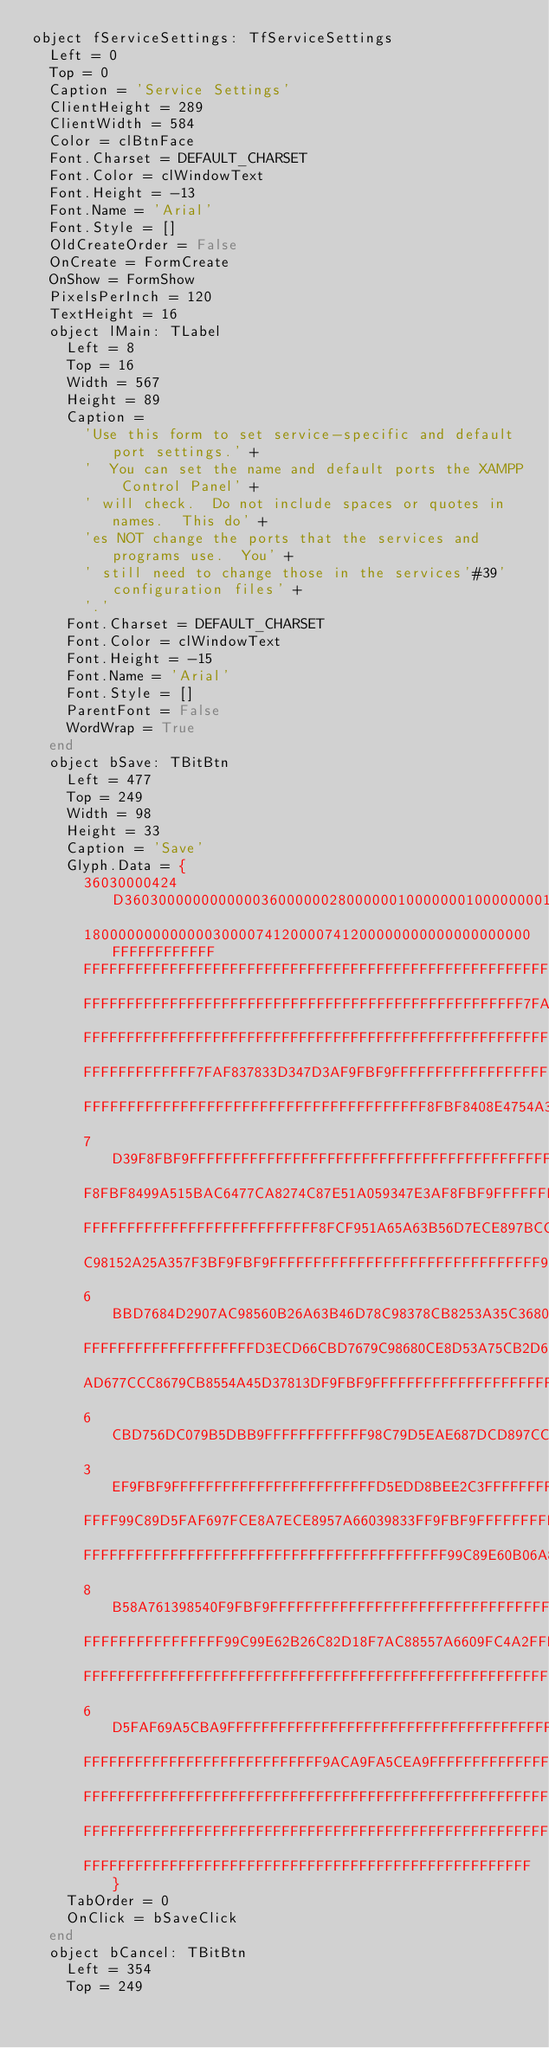<code> <loc_0><loc_0><loc_500><loc_500><_Pascal_>object fServiceSettings: TfServiceSettings
  Left = 0
  Top = 0
  Caption = 'Service Settings'
  ClientHeight = 289
  ClientWidth = 584
  Color = clBtnFace
  Font.Charset = DEFAULT_CHARSET
  Font.Color = clWindowText
  Font.Height = -13
  Font.Name = 'Arial'
  Font.Style = []
  OldCreateOrder = False
  OnCreate = FormCreate
  OnShow = FormShow
  PixelsPerInch = 120
  TextHeight = 16
  object lMain: TLabel
    Left = 8
    Top = 16
    Width = 567
    Height = 89
    Caption = 
      'Use this form to set service-specific and default port settings.' +
      '  You can set the name and default ports the XAMPP Control Panel' +
      ' will check.  Do not include spaces or quotes in names.  This do' +
      'es NOT change the ports that the services and programs use.  You' +
      ' still need to change those in the services'#39' configuration files' +
      '.'
    Font.Charset = DEFAULT_CHARSET
    Font.Color = clWindowText
    Font.Height = -15
    Font.Name = 'Arial'
    Font.Style = []
    ParentFont = False
    WordWrap = True
  end
  object bSave: TBitBtn
    Left = 477
    Top = 249
    Width = 98
    Height = 33
    Caption = 'Save'
    Glyph.Data = {
      36030000424D3603000000000000360000002800000010000000100000000100
      1800000000000003000074120000741200000000000000000000FFFFFFFFFFFF
      FFFFFFFFFFFFFFFFFFFFFFFFFFFFFFFFFFFFFFFFFFFFFFFFFFFFFFFFFFFFFFFF
      FFFFFFFFFFFFFFFFFFFFFFFFFFFFFFFFFFFFFFFFFFFFFFFFFFF7FAF7F9FBF9FF
      FFFFFFFFFFFFFFFFFFFFFFFFFFFFFFFFFFFFFFFFFFFFFFFFFFFFFFFFFFFFFFFF
      FFFFFFFFFFFFF7FAF837833D347D3AF9FBF9FFFFFFFFFFFFFFFFFFFFFFFFFFFF
      FFFFFFFFFFFFFFFFFFFFFFFFFFFFFFFFFFFFFFF8FBF8408E4754A35C4F9F5733
      7D39F8FBF9FFFFFFFFFFFFFFFFFFFFFFFFFFFFFFFFFFFFFFFFFFFFFFFFFFFFFF
      F8FBF8499A515BAC6477CA8274C87E51A059347E3AF8FBF9FFFFFFFFFFFFFFFF
      FFFFFFFFFFFFFFFFFFFFFFFFFFF8FCF951A65A63B56D7ECE897BCC8776CA8176
      C98152A25A357F3BF9FBF9FFFFFFFFFFFFFFFFFFFFFFFFFFFFFFF9FCFA59B063
      6BBD7684D2907AC98560B26A63B46D78C98378CB8253A35C36803CF9FBF9FFFF
      FFFFFFFFFFFFFFFFFFFFD3ECD66CBD7679C98680CE8D53A75CB2D6B59CC9A05C
      AD677CCC8679CB8554A45D37813DF9FBF9FFFFFFFFFFFFFFFFFFFFFFFFD9EFDC
      6CBD756DC079B5DBB9FFFFFFFFFFFF98C79D5EAE687DCD897CCD8756A55F3882
      3EF9FBF9FFFFFFFFFFFFFFFFFFFFFFFFD5EDD8BEE2C3FFFFFFFFFFFFFFFFFFFF
      FFFF99C89D5FAF697FCE8A7ECE8957A66039833FF9FBF9FFFFFFFFFFFFFFFFFF
      FFFFFFFFFFFFFFFFFFFFFFFFFFFFFFFFFFFFFFFFFF99C89E60B06A81CF8D7FCF
      8B58A761398540F9FBF9FFFFFFFFFFFFFFFFFFFFFFFFFFFFFFFFFFFFFFFFFFFF
      FFFFFFFFFFFFFFFF99C99E62B26C82D18F7AC88557A6609FC4A2FFFFFFFFFFFF
      FFFFFFFFFFFFFFFFFFFFFFFFFFFFFFFFFFFFFFFFFFFFFFFFFFFFFF9ACA9F63B3
      6D5FAF69A5CBA9FFFFFFFFFFFFFFFFFFFFFFFFFFFFFFFFFFFFFFFFFFFFFFFFFF
      FFFFFFFFFFFFFFFFFFFFFFFFFFFF9ACA9FA5CEA9FFFFFFFFFFFFFFFFFFFFFFFF
      FFFFFFFFFFFFFFFFFFFFFFFFFFFFFFFFFFFFFFFFFFFFFFFFFFFFFFFFFFFFFFFF
      FFFFFFFFFFFFFFFFFFFFFFFFFFFFFFFFFFFFFFFFFFFFFFFFFFFFFFFFFFFFFFFF
      FFFFFFFFFFFFFFFFFFFFFFFFFFFFFFFFFFFFFFFFFFFFFFFFFFFF}
    TabOrder = 0
    OnClick = bSaveClick
  end
  object bCancel: TBitBtn
    Left = 354
    Top = 249</code> 